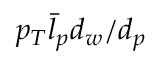<formula> <loc_0><loc_0><loc_500><loc_500>p _ { T } \bar { l } _ { p } d _ { w } / d _ { p }</formula> 